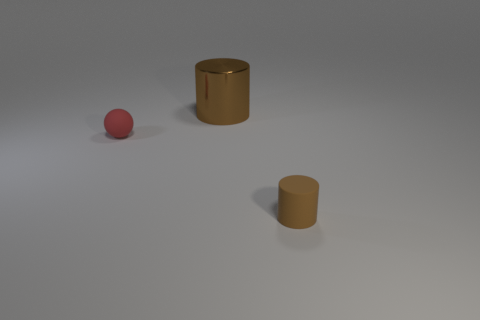Add 1 blue rubber things. How many blue rubber things exist? 1 Add 1 blue rubber blocks. How many objects exist? 4 Subtract 0 red cubes. How many objects are left? 3 Subtract all cylinders. How many objects are left? 1 Subtract 1 cylinders. How many cylinders are left? 1 Subtract all blue cylinders. Subtract all green balls. How many cylinders are left? 2 Subtract all tiny spheres. Subtract all brown rubber things. How many objects are left? 1 Add 3 brown matte cylinders. How many brown matte cylinders are left? 4 